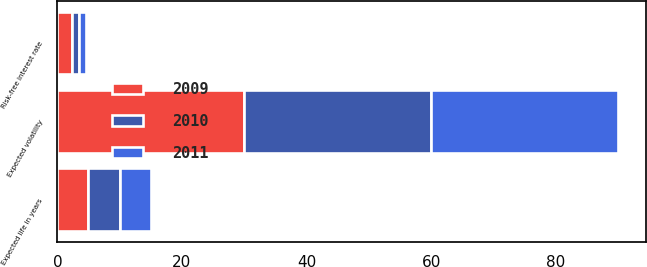Convert chart to OTSL. <chart><loc_0><loc_0><loc_500><loc_500><stacked_bar_chart><ecel><fcel>Risk-free interest rate<fcel>Expected life in years<fcel>Expected volatility<nl><fcel>2010<fcel>1.09<fcel>5<fcel>30<nl><fcel>2011<fcel>1.17<fcel>5<fcel>30<nl><fcel>2009<fcel>2.33<fcel>5<fcel>30<nl></chart> 